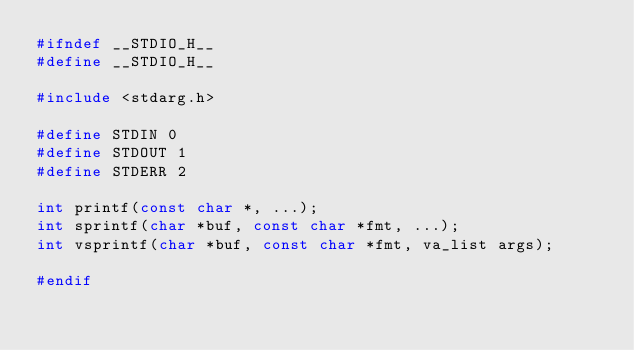<code> <loc_0><loc_0><loc_500><loc_500><_C_>#ifndef __STDIO_H__
#define __STDIO_H__

#include <stdarg.h>

#define STDIN 0
#define STDOUT 1
#define STDERR 2

int printf(const char *, ...);
int sprintf(char *buf, const char *fmt, ...);
int vsprintf(char *buf, const char *fmt, va_list args);

#endif
</code> 